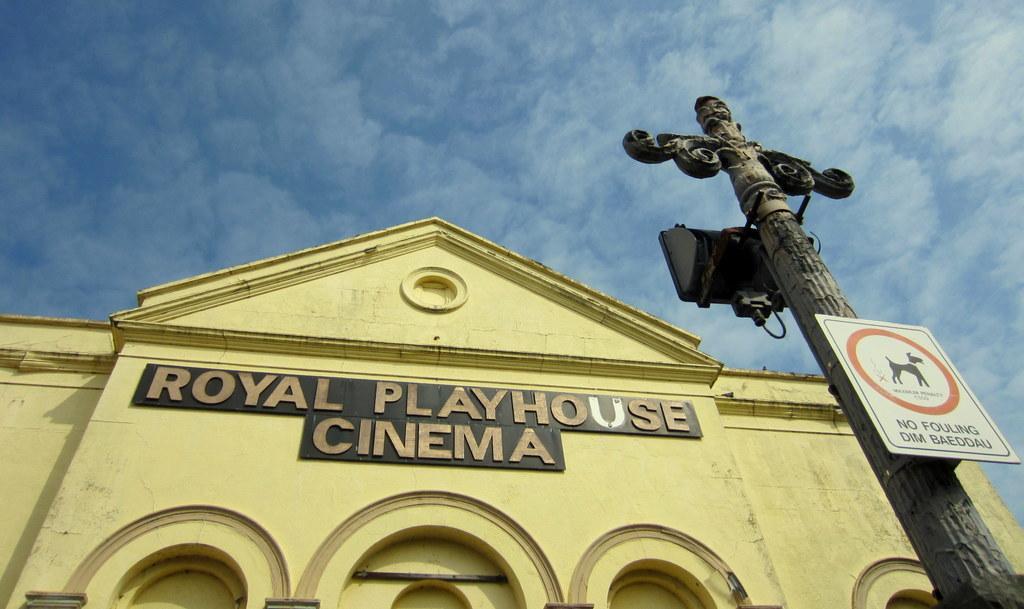Can you describe this image briefly? In this picture there is a building, a pole and a hoarding. Sky is clear and it is sunny. 